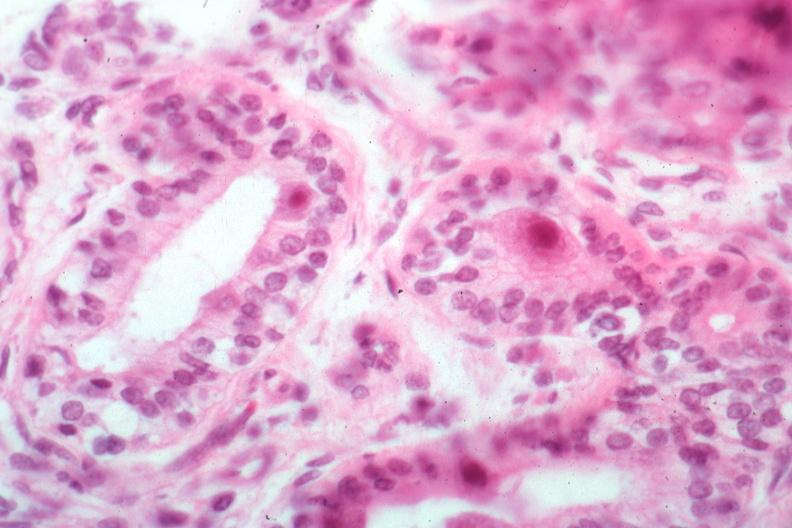what is present?
Answer the question using a single word or phrase. Submaxillary gland 